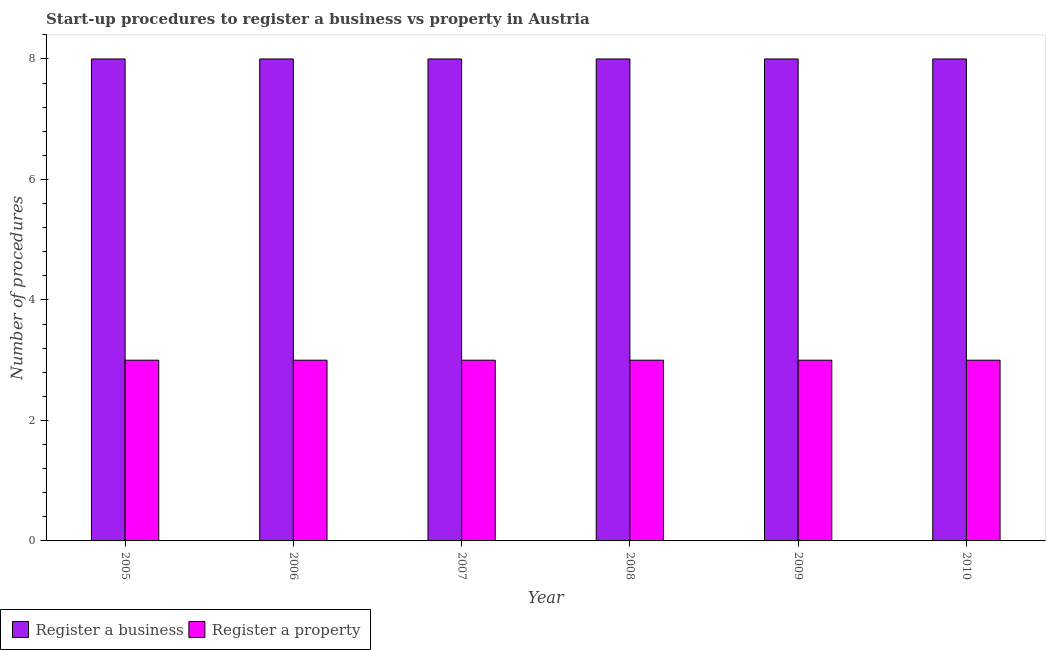How many groups of bars are there?
Your answer should be very brief. 6. Are the number of bars on each tick of the X-axis equal?
Your answer should be compact. Yes. How many bars are there on the 2nd tick from the left?
Make the answer very short. 2. What is the number of procedures to register a property in 2007?
Your answer should be very brief. 3. Across all years, what is the maximum number of procedures to register a business?
Ensure brevity in your answer.  8. Across all years, what is the minimum number of procedures to register a property?
Provide a short and direct response. 3. In which year was the number of procedures to register a business maximum?
Keep it short and to the point. 2005. What is the total number of procedures to register a business in the graph?
Your response must be concise. 48. What is the average number of procedures to register a business per year?
Make the answer very short. 8. In how many years, is the number of procedures to register a property greater than 2.4?
Give a very brief answer. 6. What is the ratio of the number of procedures to register a property in 2007 to that in 2010?
Keep it short and to the point. 1. What does the 2nd bar from the left in 2005 represents?
Offer a terse response. Register a property. What does the 2nd bar from the right in 2006 represents?
Your response must be concise. Register a business. How many bars are there?
Make the answer very short. 12. Are all the bars in the graph horizontal?
Offer a very short reply. No. What is the difference between two consecutive major ticks on the Y-axis?
Offer a terse response. 2. Are the values on the major ticks of Y-axis written in scientific E-notation?
Ensure brevity in your answer.  No. Does the graph contain any zero values?
Your response must be concise. No. Does the graph contain grids?
Ensure brevity in your answer.  No. How are the legend labels stacked?
Keep it short and to the point. Horizontal. What is the title of the graph?
Your response must be concise. Start-up procedures to register a business vs property in Austria. What is the label or title of the X-axis?
Your answer should be very brief. Year. What is the label or title of the Y-axis?
Ensure brevity in your answer.  Number of procedures. What is the Number of procedures of Register a property in 2006?
Offer a very short reply. 3. What is the Number of procedures in Register a property in 2007?
Provide a short and direct response. 3. What is the Number of procedures of Register a business in 2009?
Your answer should be very brief. 8. What is the Number of procedures of Register a property in 2009?
Your answer should be very brief. 3. What is the Number of procedures in Register a business in 2010?
Ensure brevity in your answer.  8. Across all years, what is the maximum Number of procedures of Register a business?
Offer a very short reply. 8. Across all years, what is the maximum Number of procedures of Register a property?
Provide a short and direct response. 3. What is the total Number of procedures in Register a business in the graph?
Keep it short and to the point. 48. What is the difference between the Number of procedures in Register a property in 2005 and that in 2006?
Offer a very short reply. 0. What is the difference between the Number of procedures in Register a business in 2005 and that in 2007?
Give a very brief answer. 0. What is the difference between the Number of procedures in Register a property in 2005 and that in 2009?
Your answer should be compact. 0. What is the difference between the Number of procedures in Register a business in 2005 and that in 2010?
Offer a very short reply. 0. What is the difference between the Number of procedures of Register a business in 2006 and that in 2007?
Offer a terse response. 0. What is the difference between the Number of procedures in Register a property in 2006 and that in 2007?
Offer a very short reply. 0. What is the difference between the Number of procedures in Register a property in 2006 and that in 2008?
Offer a very short reply. 0. What is the difference between the Number of procedures in Register a business in 2006 and that in 2009?
Your answer should be very brief. 0. What is the difference between the Number of procedures of Register a property in 2006 and that in 2009?
Your answer should be compact. 0. What is the difference between the Number of procedures in Register a business in 2006 and that in 2010?
Ensure brevity in your answer.  0. What is the difference between the Number of procedures of Register a business in 2007 and that in 2008?
Provide a short and direct response. 0. What is the difference between the Number of procedures in Register a property in 2007 and that in 2008?
Give a very brief answer. 0. What is the difference between the Number of procedures of Register a business in 2008 and that in 2010?
Provide a succinct answer. 0. What is the difference between the Number of procedures in Register a property in 2008 and that in 2010?
Provide a succinct answer. 0. What is the difference between the Number of procedures in Register a business in 2009 and that in 2010?
Keep it short and to the point. 0. What is the difference between the Number of procedures of Register a business in 2005 and the Number of procedures of Register a property in 2008?
Provide a succinct answer. 5. What is the difference between the Number of procedures in Register a business in 2005 and the Number of procedures in Register a property in 2010?
Offer a very short reply. 5. What is the difference between the Number of procedures in Register a business in 2007 and the Number of procedures in Register a property in 2008?
Your answer should be very brief. 5. What is the difference between the Number of procedures of Register a business in 2008 and the Number of procedures of Register a property in 2009?
Your answer should be very brief. 5. What is the difference between the Number of procedures in Register a business in 2008 and the Number of procedures in Register a property in 2010?
Your response must be concise. 5. What is the difference between the Number of procedures in Register a business in 2009 and the Number of procedures in Register a property in 2010?
Offer a terse response. 5. What is the average Number of procedures of Register a business per year?
Your answer should be compact. 8. In the year 2005, what is the difference between the Number of procedures in Register a business and Number of procedures in Register a property?
Your answer should be compact. 5. In the year 2006, what is the difference between the Number of procedures in Register a business and Number of procedures in Register a property?
Your answer should be very brief. 5. In the year 2010, what is the difference between the Number of procedures in Register a business and Number of procedures in Register a property?
Your answer should be compact. 5. What is the ratio of the Number of procedures of Register a business in 2005 to that in 2006?
Provide a short and direct response. 1. What is the ratio of the Number of procedures in Register a property in 2005 to that in 2006?
Keep it short and to the point. 1. What is the ratio of the Number of procedures in Register a business in 2005 to that in 2007?
Your answer should be very brief. 1. What is the ratio of the Number of procedures in Register a property in 2005 to that in 2007?
Your response must be concise. 1. What is the ratio of the Number of procedures in Register a business in 2005 to that in 2008?
Give a very brief answer. 1. What is the ratio of the Number of procedures in Register a property in 2005 to that in 2008?
Offer a terse response. 1. What is the ratio of the Number of procedures of Register a property in 2005 to that in 2009?
Provide a succinct answer. 1. What is the ratio of the Number of procedures in Register a property in 2005 to that in 2010?
Give a very brief answer. 1. What is the ratio of the Number of procedures in Register a property in 2006 to that in 2007?
Ensure brevity in your answer.  1. What is the ratio of the Number of procedures in Register a business in 2006 to that in 2008?
Offer a terse response. 1. What is the ratio of the Number of procedures of Register a property in 2006 to that in 2008?
Provide a short and direct response. 1. What is the ratio of the Number of procedures in Register a business in 2006 to that in 2009?
Your answer should be very brief. 1. What is the ratio of the Number of procedures in Register a property in 2006 to that in 2010?
Keep it short and to the point. 1. What is the ratio of the Number of procedures of Register a business in 2007 to that in 2008?
Your response must be concise. 1. What is the ratio of the Number of procedures of Register a business in 2007 to that in 2009?
Give a very brief answer. 1. What is the ratio of the Number of procedures in Register a property in 2007 to that in 2010?
Keep it short and to the point. 1. What is the ratio of the Number of procedures in Register a business in 2008 to that in 2010?
Offer a terse response. 1. What is the ratio of the Number of procedures of Register a property in 2009 to that in 2010?
Provide a succinct answer. 1. 